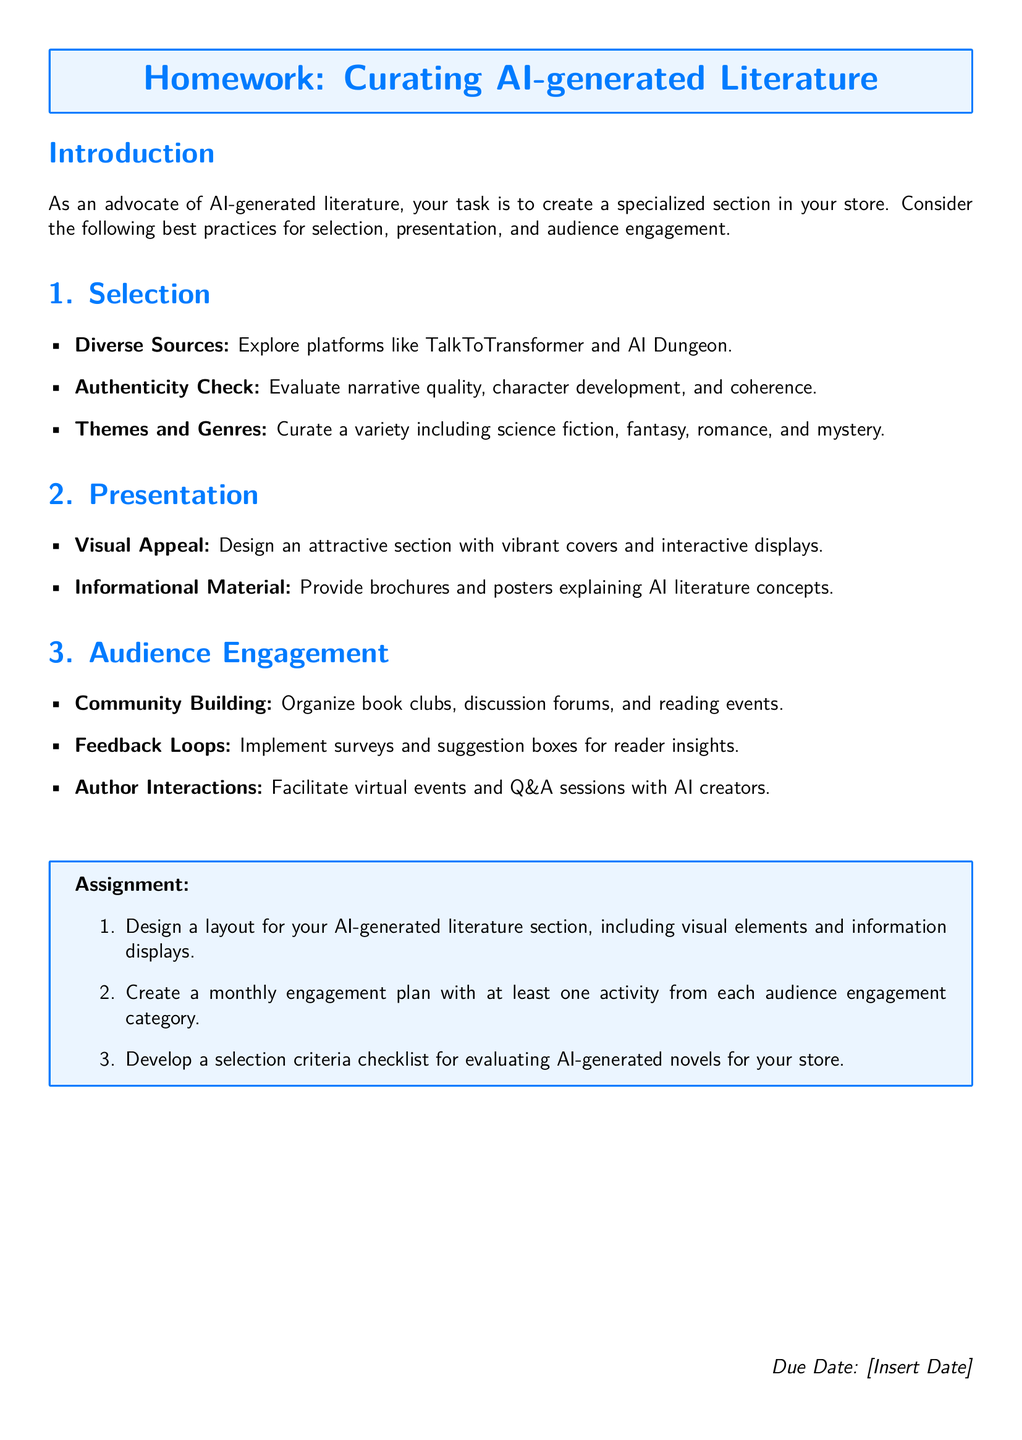What are the main categories emphasized for audience engagement? The document lists specific audience engagement strategies, focusing on community building, feedback loops, and author interactions.
Answer: Community building, feedback loops, author interactions What is one platform suggested for exploring AI-generated literature? The document mentions platforms that help in sourcing AI-generated content, with TalkToTransformer being one of them.
Answer: TalkToTransformer How many engagement activities are required in the monthly engagement plan? The assignment specifies that at least one activity should be created from each category for audience engagement, which implies a total of three activities.
Answer: Three What is the due date format indicated in the document? The assignment section includes a placeholder where the date can be inserted, suggesting flexibility in setting a specific date for submissions.
Answer: Insert Date What are two types of visual elements recommended for the literature section's presentation? The document suggests creating an attractive section with vibrant covers and interactive displays, making these two visual elements key.
Answer: Vibrant covers, interactive displays Why is authenticity checking important in the selection process? The need for narrative quality, character development, and coherence underlines the significance of authenticity in ensuring good literature.
Answer: Narrative quality, character development, coherence 